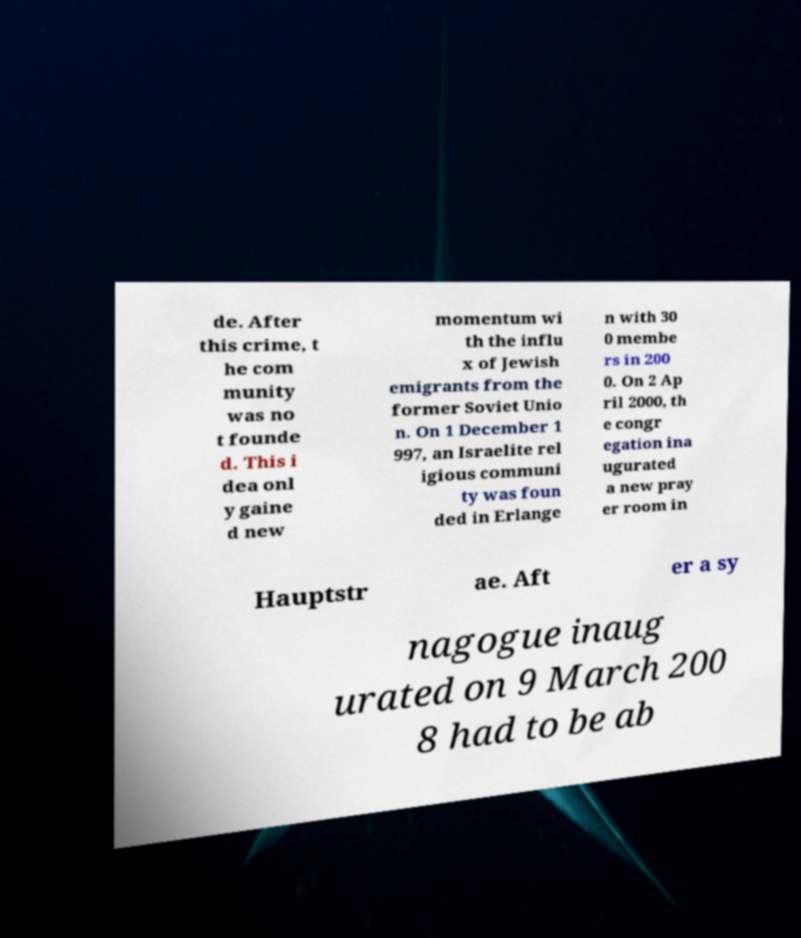For documentation purposes, I need the text within this image transcribed. Could you provide that? de. After this crime, t he com munity was no t founde d. This i dea onl y gaine d new momentum wi th the influ x of Jewish emigrants from the former Soviet Unio n. On 1 December 1 997, an Israelite rel igious communi ty was foun ded in Erlange n with 30 0 membe rs in 200 0. On 2 Ap ril 2000, th e congr egation ina ugurated a new pray er room in Hauptstr ae. Aft er a sy nagogue inaug urated on 9 March 200 8 had to be ab 